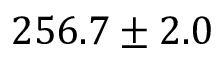Convert formula to latex. <formula><loc_0><loc_0><loc_500><loc_500>2 5 6 . 7 \pm 2 . 0</formula> 